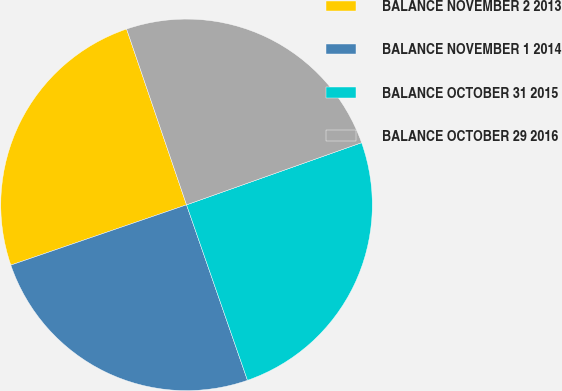Convert chart. <chart><loc_0><loc_0><loc_500><loc_500><pie_chart><fcel>BALANCE NOVEMBER 2 2013<fcel>BALANCE NOVEMBER 1 2014<fcel>BALANCE OCTOBER 31 2015<fcel>BALANCE OCTOBER 29 2016<nl><fcel>25.03%<fcel>25.06%<fcel>25.11%<fcel>24.8%<nl></chart> 